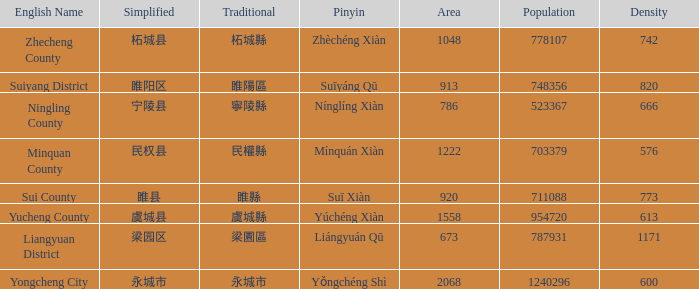Parse the table in full. {'header': ['English Name', 'Simplified', 'Traditional', 'Pinyin', 'Area', 'Population', 'Density'], 'rows': [['Zhecheng County', '柘城县', '柘城縣', 'Zhèchéng Xiàn', '1048', '778107', '742'], ['Suiyang District', '睢阳区', '睢陽區', 'Suīyáng Qū', '913', '748356', '820'], ['Ningling County', '宁陵县', '寧陵縣', 'Nínglíng Xiàn', '786', '523367', '666'], ['Minquan County', '民权县', '民權縣', 'Mínquán Xiàn', '1222', '703379', '576'], ['Sui County', '睢县', '睢縣', 'Suī Xiàn', '920', '711088', '773'], ['Yucheng County', '虞城县', '虞城縣', 'Yúchéng Xiàn', '1558', '954720', '613'], ['Liangyuan District', '梁园区', '梁園區', 'Liángyuán Qū', '673', '787931', '1171'], ['Yongcheng City', '永城市', '永城市', 'Yǒngchéng Shì', '2068', '1240296', '600']]} What is the traditional with density of 820? 睢陽區. 